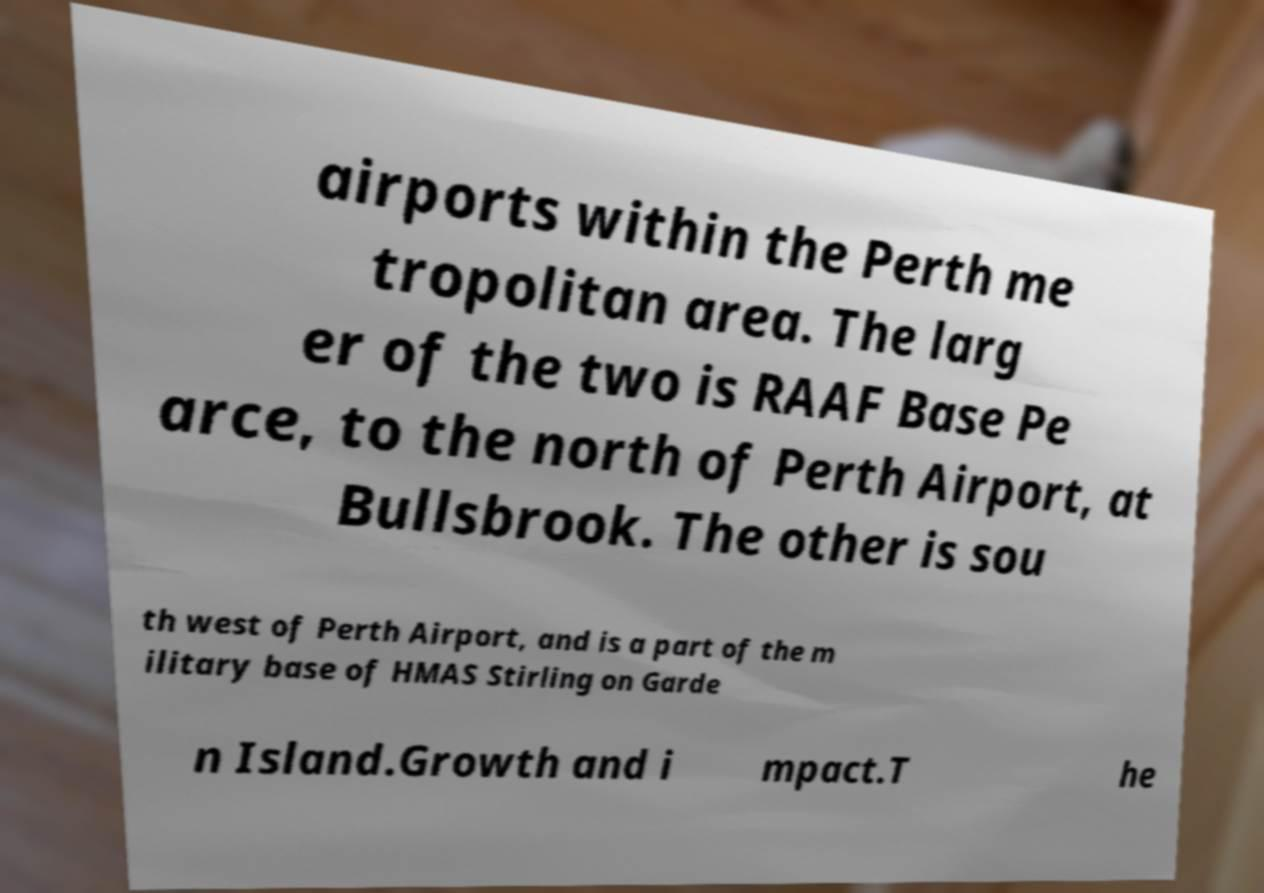Can you read and provide the text displayed in the image?This photo seems to have some interesting text. Can you extract and type it out for me? airports within the Perth me tropolitan area. The larg er of the two is RAAF Base Pe arce, to the north of Perth Airport, at Bullsbrook. The other is sou th west of Perth Airport, and is a part of the m ilitary base of HMAS Stirling on Garde n Island.Growth and i mpact.T he 